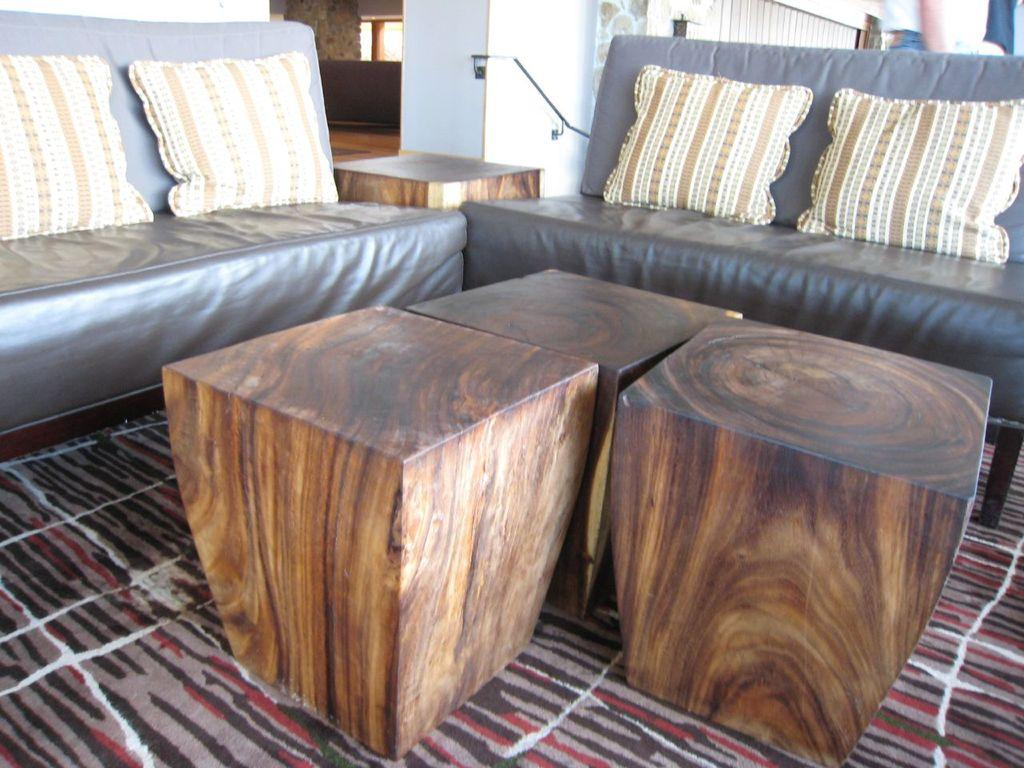What type of furniture is present in the image? There is a sofa in the image. What is placed on the sofa? There is a pillow on the sofa. What type of tables are in the image? There are wooden tables in the image. What type of floor covering is visible in the image? There is a carpet in the image. What type of fog can be seen in the image? There is no fog present in the image. What time of day is depicted in the image? The time of day cannot be determined from the image, as there are no clues about the lighting or shadows. 